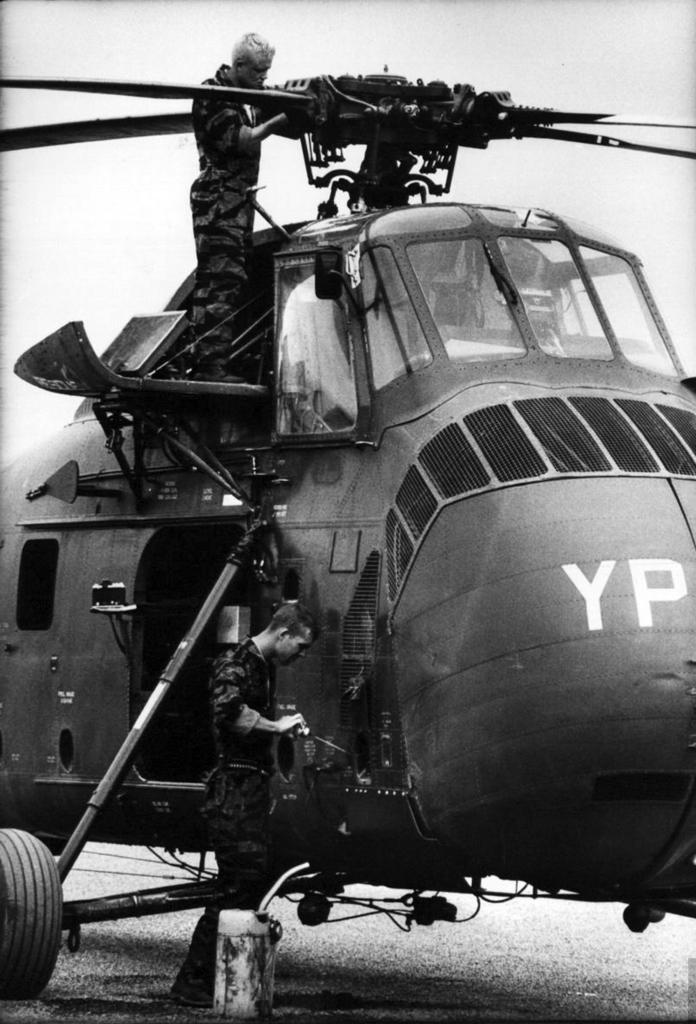What two letters are on the front of the helicopter?
Offer a very short reply. Yp. 